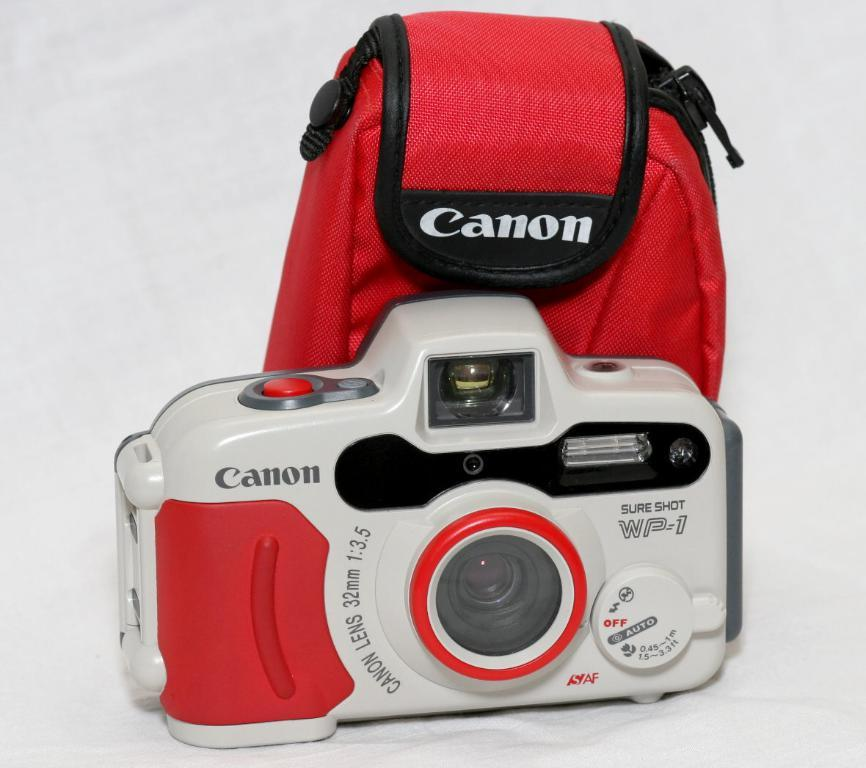What object is the main subject of the image? There is a camera in the image. What is the color of the surface on which the camera is placed? The camera is placed on a white surface. What else can be seen in the image besides the camera? There is a pouch visible behind the camera. What type of metal is the army using to promote growth in the image? There is no mention of metal, army, or growth in the image. The image only features a camera placed on a white surface with a pouch visible behind it. 